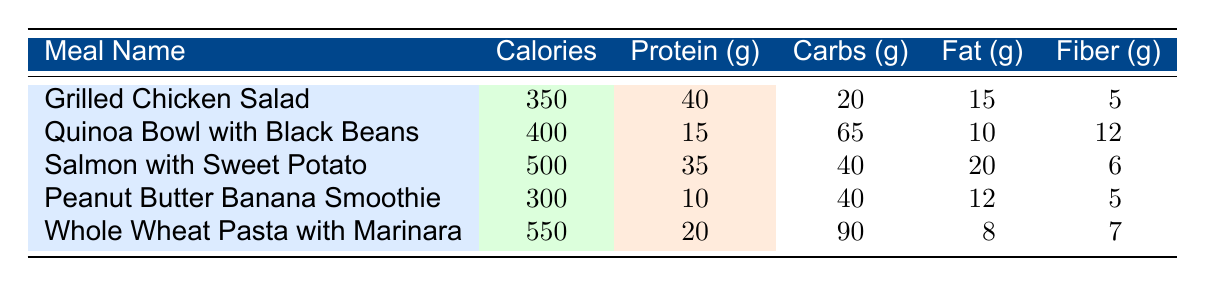What is the meal with the highest protein content? From the table, we can see the protein contents of each meal: Grilled Chicken Salad has 40g, Quinoa Bowl with Black Beans has 15g, Salmon with Sweet Potato has 35g, Peanut Butter Banana Smoothie has 10g, and Whole Wheat Pasta with Marinara has 20g. The highest value is 40g from the Grilled Chicken Salad.
Answer: Grilled Chicken Salad How many calories are in the Quinoa Bowl with Black Beans? The Quinoa Bowl with Black Beans has a calorie value listed directly in the table, which is 400 calories.
Answer: 400 calories Which meal has the least amount of fat? By reviewing the fat contents for each meal: Grilled Chicken Salad has 15g, Quinoa Bowl with Black Beans has 10g, Salmon with Sweet Potato has 20g, Peanut Butter Banana Smoothie has 12g, and Whole Wheat Pasta with Marinara has 8g. The meal with the least fat is the Whole Wheat Pasta with Marinara at 8g.
Answer: Whole Wheat Pasta with Marinara What is the average carbohydrate content of the meals listed in the table? We need to calculate the total carbohydrates from all meals: 20g + 65g + 40g + 40g + 90g = 255g. Then, divide by the number of meals (5) to find the average: 255g / 5 = 51g.
Answer: 51g Is the Peanut Butter Banana Smoothie higher in calories than the Grilled Chicken Salad? Looking at the table, the Peanut Butter Banana Smoothie has 300 calories and the Grilled Chicken Salad has 350 calories. Since 300 is less than 350, the statement is false.
Answer: No Which meal has both the highest calorie and fat content combined? First, we need to calculate the combined values of calories and fat for each meal: Grilled Chicken Salad: 350 + 15 = 365, Quinoa Bowl with Black Beans: 400 + 10 = 410, Salmon with Sweet Potato: 500 + 20 = 520, Peanut Butter Banana Smoothie: 300 + 12 = 312, and Whole Wheat Pasta with Marinara: 550 + 8 = 558. The meal with the highest combined value is Whole Wheat Pasta with Marinara at 558.
Answer: Whole Wheat Pasta with Marinara Does the Salmon with Sweet Potato have more protein than the Whole Wheat Pasta with Marinara? The Salmon with Sweet Potato contains 35g of protein while the Whole Wheat Pasta with Marinara has 20g of protein. Since 35 is more than 20, the statement is true.
Answer: Yes What meal has the highest amount of fiber and what is that amount? Reviewing the fiber values: Grilled Chicken Salad has 5g, Quinoa Bowl with Black Beans has 12g, Salmon with Sweet Potato has 6g, Peanut Butter Banana Smoothie has 5g, and Whole Wheat Pasta with Marinara has 7g. The Quinoa Bowl with Black Beans has the highest fiber content at 12g.
Answer: Quinoa Bowl with Black Beans, 12g 